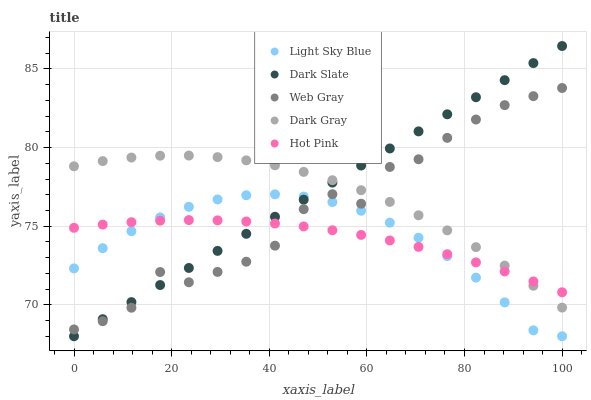Does Hot Pink have the minimum area under the curve?
Answer yes or no. Yes. Does Dark Slate have the maximum area under the curve?
Answer yes or no. Yes. Does Light Sky Blue have the minimum area under the curve?
Answer yes or no. No. Does Light Sky Blue have the maximum area under the curve?
Answer yes or no. No. Is Dark Slate the smoothest?
Answer yes or no. Yes. Is Web Gray the roughest?
Answer yes or no. Yes. Is Light Sky Blue the smoothest?
Answer yes or no. No. Is Light Sky Blue the roughest?
Answer yes or no. No. Does Dark Slate have the lowest value?
Answer yes or no. Yes. Does Web Gray have the lowest value?
Answer yes or no. No. Does Dark Slate have the highest value?
Answer yes or no. Yes. Does Light Sky Blue have the highest value?
Answer yes or no. No. Is Light Sky Blue less than Dark Gray?
Answer yes or no. Yes. Is Dark Gray greater than Light Sky Blue?
Answer yes or no. Yes. Does Dark Slate intersect Dark Gray?
Answer yes or no. Yes. Is Dark Slate less than Dark Gray?
Answer yes or no. No. Is Dark Slate greater than Dark Gray?
Answer yes or no. No. Does Light Sky Blue intersect Dark Gray?
Answer yes or no. No. 